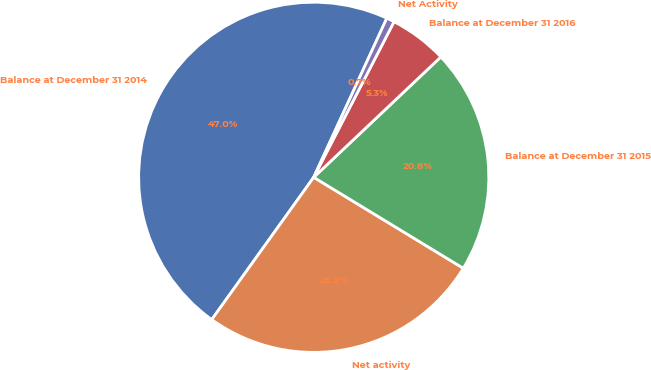<chart> <loc_0><loc_0><loc_500><loc_500><pie_chart><fcel>Balance at December 31 2014<fcel>Net activity<fcel>Balance at December 31 2015<fcel>Balance at December 31 2016<fcel>Net Activity<nl><fcel>46.96%<fcel>26.2%<fcel>20.76%<fcel>5.35%<fcel>0.73%<nl></chart> 